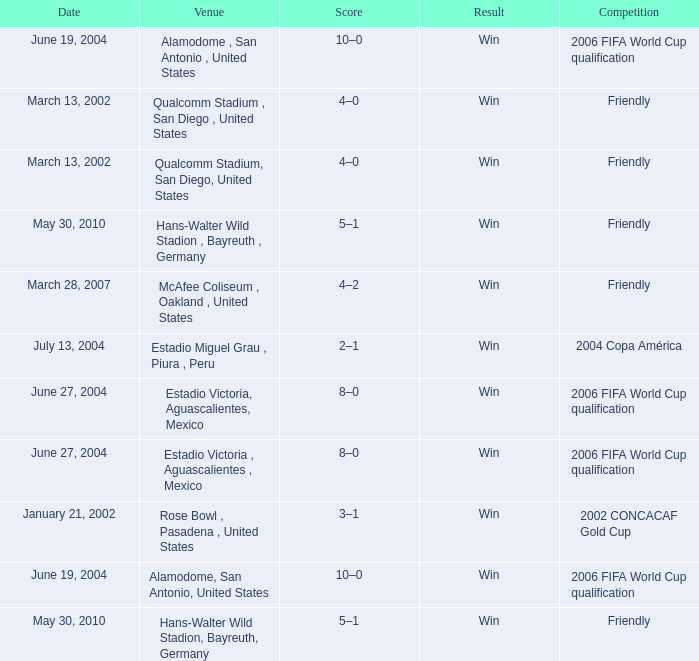On which date did the 2006 fifa world cup qualification take place at alamodome, san antonio, united states? June 19, 2004, June 19, 2004. 